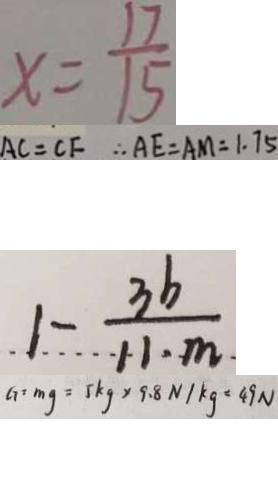Convert formula to latex. <formula><loc_0><loc_0><loc_500><loc_500>x = \frac { 1 7 } { 1 5 } 
 A C = C F \therefore A E = A M = 1 . 7 5 
 1 - \frac { 3 b } { 1 1 \cdot m } 
 G = m g = 5 k g \times 9 . 8 N / k g = 4 9 N</formula> 